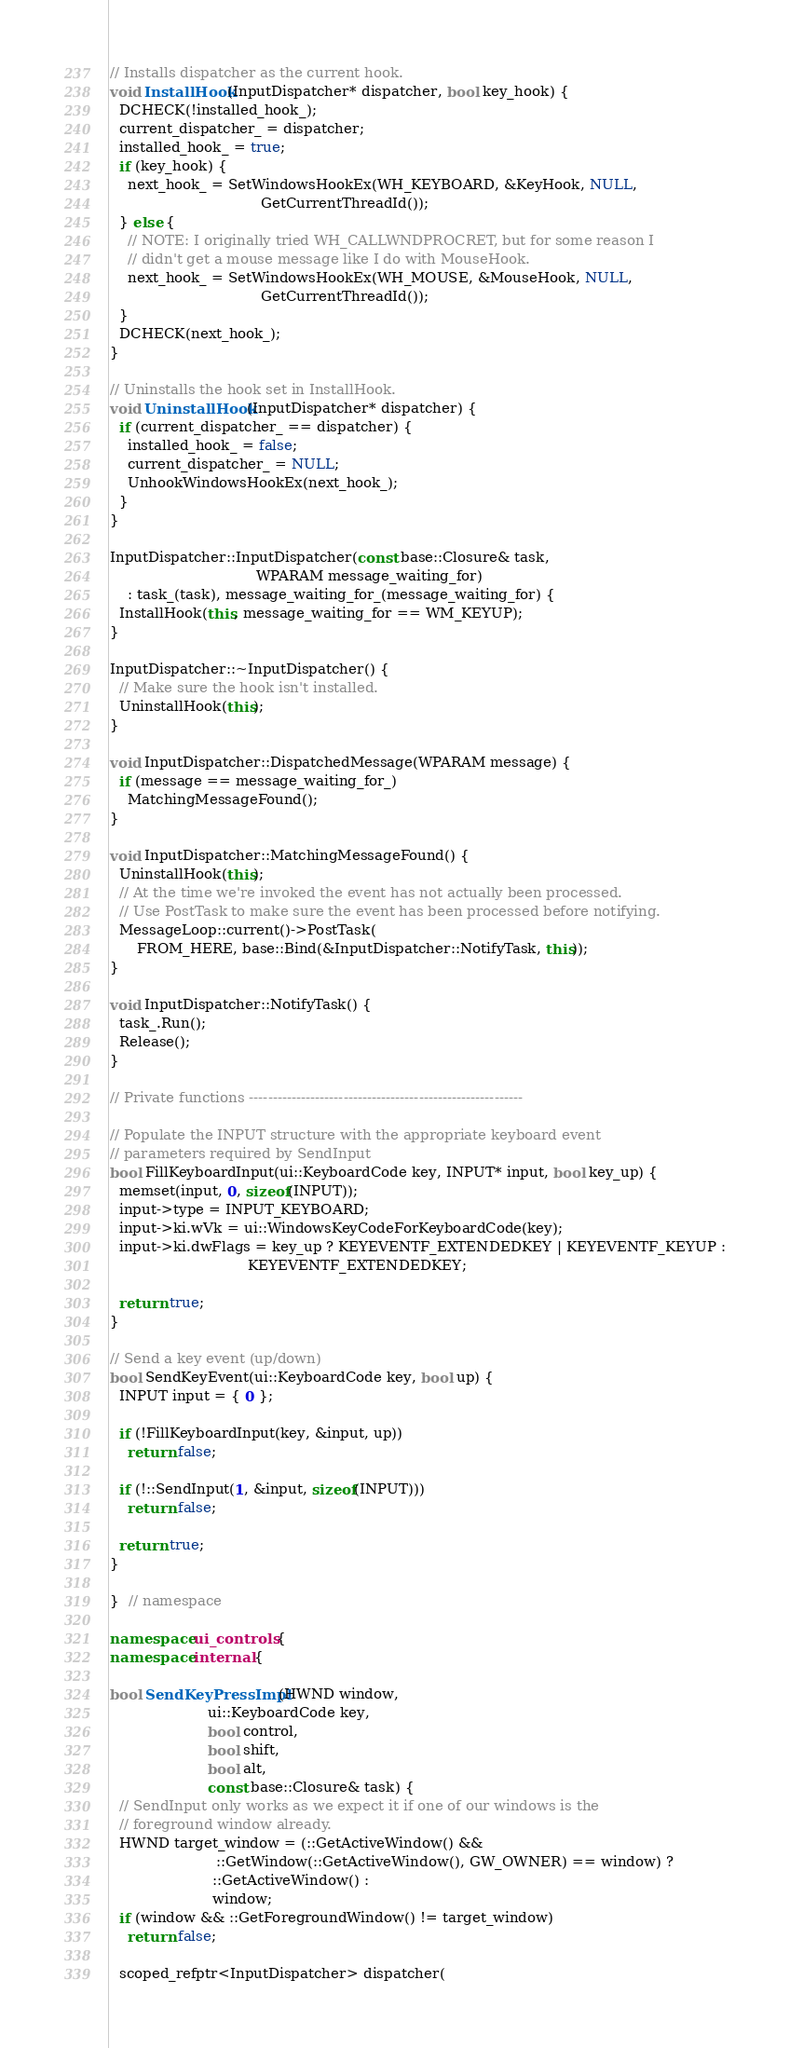<code> <loc_0><loc_0><loc_500><loc_500><_C++_>
// Installs dispatcher as the current hook.
void InstallHook(InputDispatcher* dispatcher, bool key_hook) {
  DCHECK(!installed_hook_);
  current_dispatcher_ = dispatcher;
  installed_hook_ = true;
  if (key_hook) {
    next_hook_ = SetWindowsHookEx(WH_KEYBOARD, &KeyHook, NULL,
                                  GetCurrentThreadId());
  } else {
    // NOTE: I originally tried WH_CALLWNDPROCRET, but for some reason I
    // didn't get a mouse message like I do with MouseHook.
    next_hook_ = SetWindowsHookEx(WH_MOUSE, &MouseHook, NULL,
                                  GetCurrentThreadId());
  }
  DCHECK(next_hook_);
}

// Uninstalls the hook set in InstallHook.
void UninstallHook(InputDispatcher* dispatcher) {
  if (current_dispatcher_ == dispatcher) {
    installed_hook_ = false;
    current_dispatcher_ = NULL;
    UnhookWindowsHookEx(next_hook_);
  }
}

InputDispatcher::InputDispatcher(const base::Closure& task,
                                 WPARAM message_waiting_for)
    : task_(task), message_waiting_for_(message_waiting_for) {
  InstallHook(this, message_waiting_for == WM_KEYUP);
}

InputDispatcher::~InputDispatcher() {
  // Make sure the hook isn't installed.
  UninstallHook(this);
}

void InputDispatcher::DispatchedMessage(WPARAM message) {
  if (message == message_waiting_for_)
    MatchingMessageFound();
}

void InputDispatcher::MatchingMessageFound() {
  UninstallHook(this);
  // At the time we're invoked the event has not actually been processed.
  // Use PostTask to make sure the event has been processed before notifying.
  MessageLoop::current()->PostTask(
      FROM_HERE, base::Bind(&InputDispatcher::NotifyTask, this));
}

void InputDispatcher::NotifyTask() {
  task_.Run();
  Release();
}

// Private functions ----------------------------------------------------------

// Populate the INPUT structure with the appropriate keyboard event
// parameters required by SendInput
bool FillKeyboardInput(ui::KeyboardCode key, INPUT* input, bool key_up) {
  memset(input, 0, sizeof(INPUT));
  input->type = INPUT_KEYBOARD;
  input->ki.wVk = ui::WindowsKeyCodeForKeyboardCode(key);
  input->ki.dwFlags = key_up ? KEYEVENTF_EXTENDEDKEY | KEYEVENTF_KEYUP :
                               KEYEVENTF_EXTENDEDKEY;

  return true;
}

// Send a key event (up/down)
bool SendKeyEvent(ui::KeyboardCode key, bool up) {
  INPUT input = { 0 };

  if (!FillKeyboardInput(key, &input, up))
    return false;

  if (!::SendInput(1, &input, sizeof(INPUT)))
    return false;

  return true;
}

}  // namespace

namespace ui_controls {
namespace internal {

bool SendKeyPressImpl(HWND window,
                      ui::KeyboardCode key,
                      bool control,
                      bool shift,
                      bool alt,
                      const base::Closure& task) {
  // SendInput only works as we expect it if one of our windows is the
  // foreground window already.
  HWND target_window = (::GetActiveWindow() &&
                        ::GetWindow(::GetActiveWindow(), GW_OWNER) == window) ?
                       ::GetActiveWindow() :
                       window;
  if (window && ::GetForegroundWindow() != target_window)
    return false;

  scoped_refptr<InputDispatcher> dispatcher(</code> 